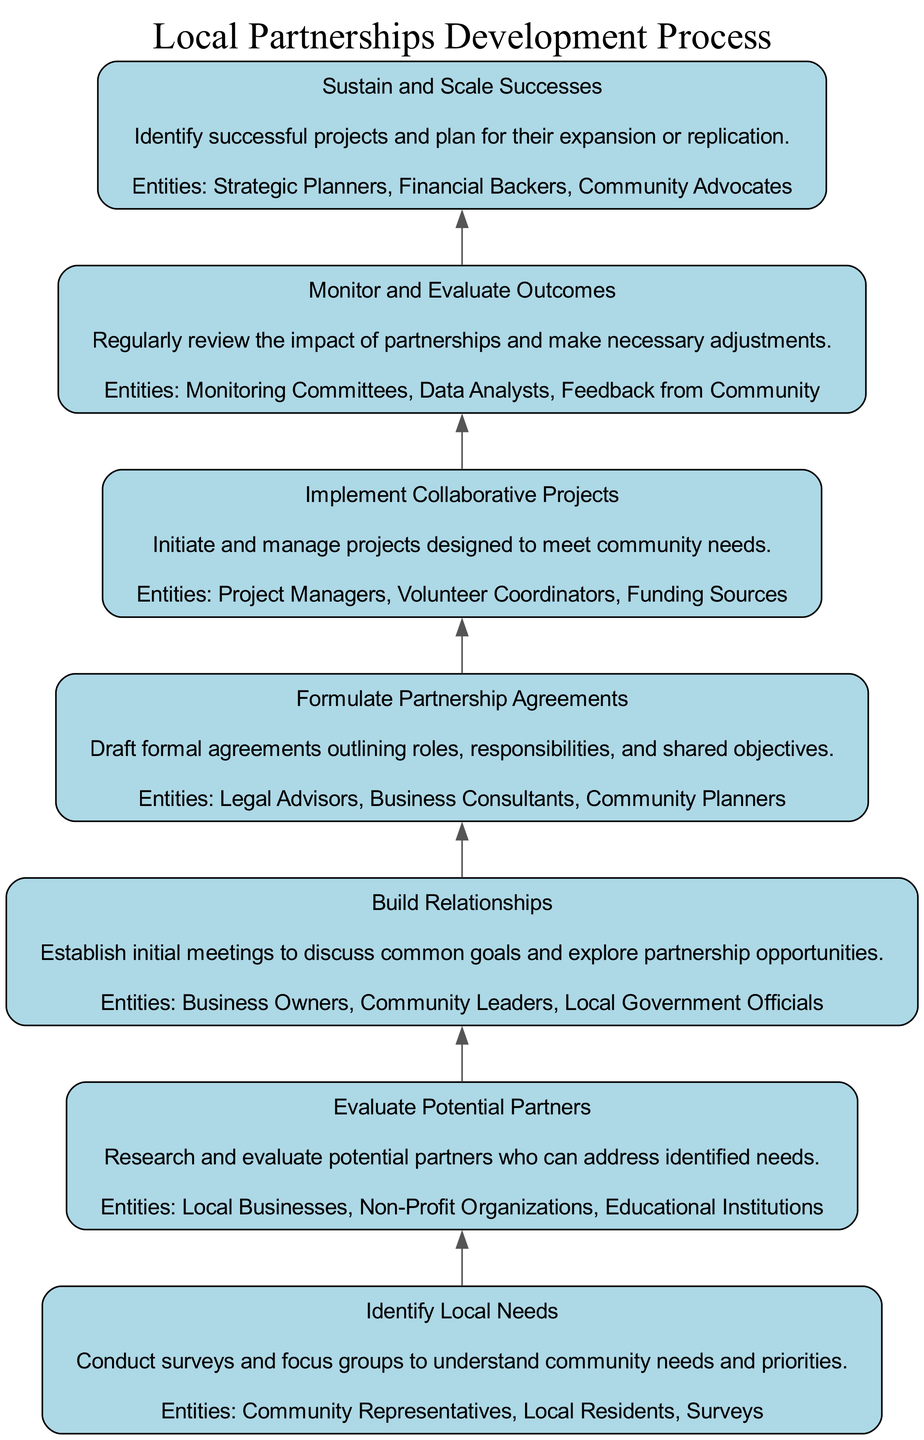What is the first step in the process? The first step listed is "Identify Local Needs," indicating the starting point of the development process.
Answer: Identify Local Needs What is the last step in the process? The last step detailed is "Sustain and Scale Successes," marking the conclusion of the development process.
Answer: Sustain and Scale Successes How many steps are there in total? There are seven steps in the Local Partnerships Development Process, as listed in the diagram.
Answer: 7 What entities are involved in evaluating potential partners? The section for "Evaluate Potential Partners" mentions "Local Businesses," "Non-Profit Organizations," and "Educational Institutions" as involved entities.
Answer: Local Businesses, Non-Profit Organizations, Educational Institutions Which step follows "Build Relationships"? According to the flow of the diagram, the step that follows "Build Relationships" is "Formulate Partnership Agreements."
Answer: Formulate Partnership Agreements What is the primary focus of monitoring and evaluating outcomes? The "Monitor and Evaluate Outcomes" step emphasizes the regular review of the impact of partnerships to make necessary adjustments.
Answer: Regular review of the impact Which step comes directly before "Implement Collaborative Projects"? The step directly preceding "Implement Collaborative Projects" is "Formulate Partnership Agreements," indicating a sequence in the process.
Answer: Formulate Partnership Agreements What are the entities involved in formulating partnership agreements? The entities listed under "Formulate Partnership Agreements" include "Legal Advisors," "Business Consultants," and "Community Planners."
Answer: Legal Advisors, Business Consultants, Community Planners What does the "Sustain and Scale Successes" step focus on? This step focuses on identifying successful projects and planning for their expansion or replication in the community.
Answer: Expansion or replication of successful projects 